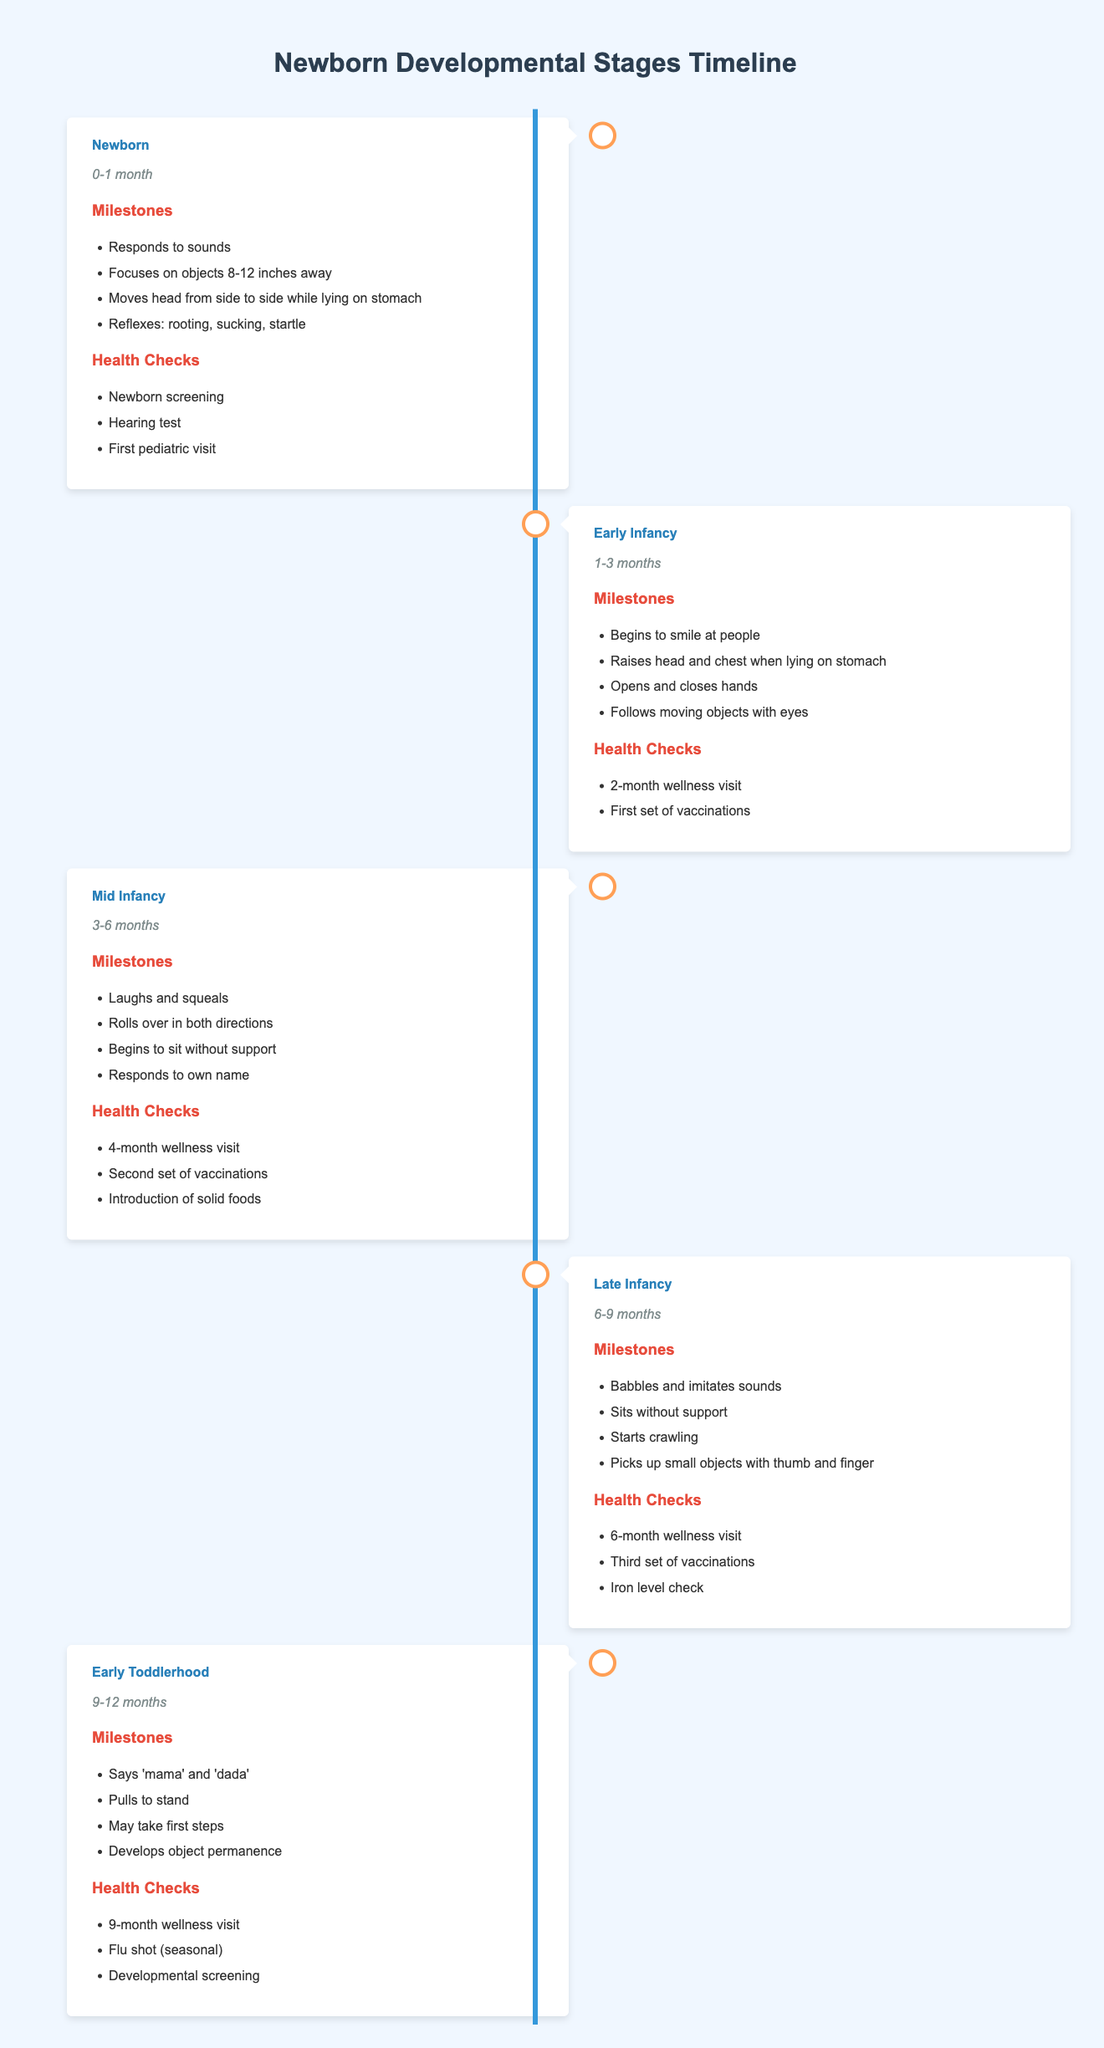What developmental stage corresponds to the age of 3-6 months? The timeline indicates that the stage corresponding to the age of 3-6 months is "Mid Infancy."
Answer: Mid Infancy How many health checks are listed for the "Newborn" stage? The "Newborn" stage includes three health checks: Newborn screening, Hearing test, and First pediatric visit. Therefore, the count is three.
Answer: 3 During which stage does a child typically begin to smile at people? The timeline specifies that a child typically begins to smile at people during the "Early Infancy" stage, which is from 1 to 3 months of age.
Answer: Early Infancy Does the "Late Infancy" stage include the introduction of solid foods? No, the "Late Infancy" stage does not include the introduction of solid foods; this milestone occurs during the "Mid Infancy" stage.
Answer: No What milestones can be observed during the "Early Toddlerhood" stage? The "Early Toddlerhood" stage consists of four milestones: Says 'mama' and 'dada', Pulls to stand, May take first steps, and Develops object permanence.
Answer: Says 'mama' and 'dada'; Pulls to stand; May take first steps; Develops object permanence What is the total number of milestones across all developmental stages? Each stage has a different number of milestones: Newborn (4), Early Infancy (4), Mid Infancy (4), Late Infancy (4), and Early Toddlerhood (4), totaling 20 milestones.
Answer: 20 Is the "9-month wellness visit" a health check during the "Mid Infancy" stage? No, the "9-month wellness visit" is a health check in the "Early Toddlerhood" stage, which is from 9 to 12 months.
Answer: No How many stages involve a child sitting without support? Two stages involve a child sitting without support: "Mid Infancy" (begins to sit without support) and "Late Infancy" (sits without support).
Answer: 2 What are the differences in health checks between the "Mid Infancy" and "Late Infancy" stages? "Mid Infancy" includes a 4-month wellness visit, second set of vaccinations, and introduction of solid foods, whereas "Late Infancy" includes a 6-month wellness visit, third set of vaccinations, and iron level check, demonstrating differences in wellness focus and nutritional checks.
Answer: Differences in types and focus of health checks 